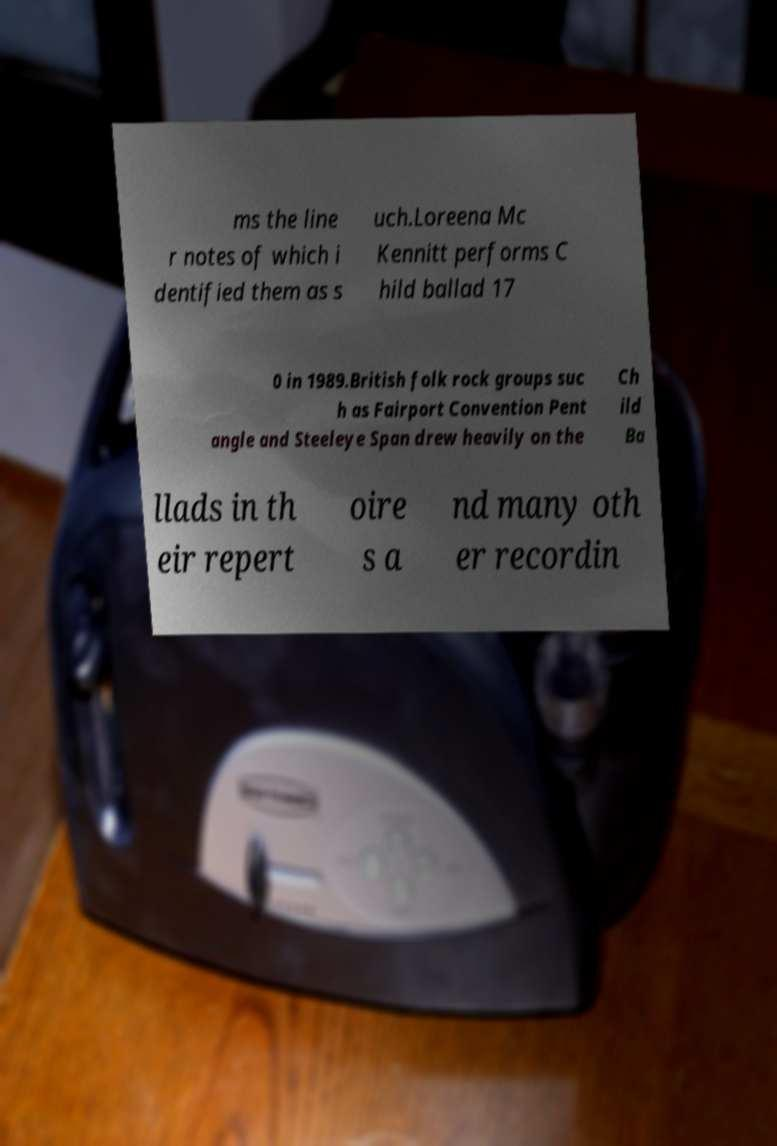I need the written content from this picture converted into text. Can you do that? ms the line r notes of which i dentified them as s uch.Loreena Mc Kennitt performs C hild ballad 17 0 in 1989.British folk rock groups suc h as Fairport Convention Pent angle and Steeleye Span drew heavily on the Ch ild Ba llads in th eir repert oire s a nd many oth er recordin 